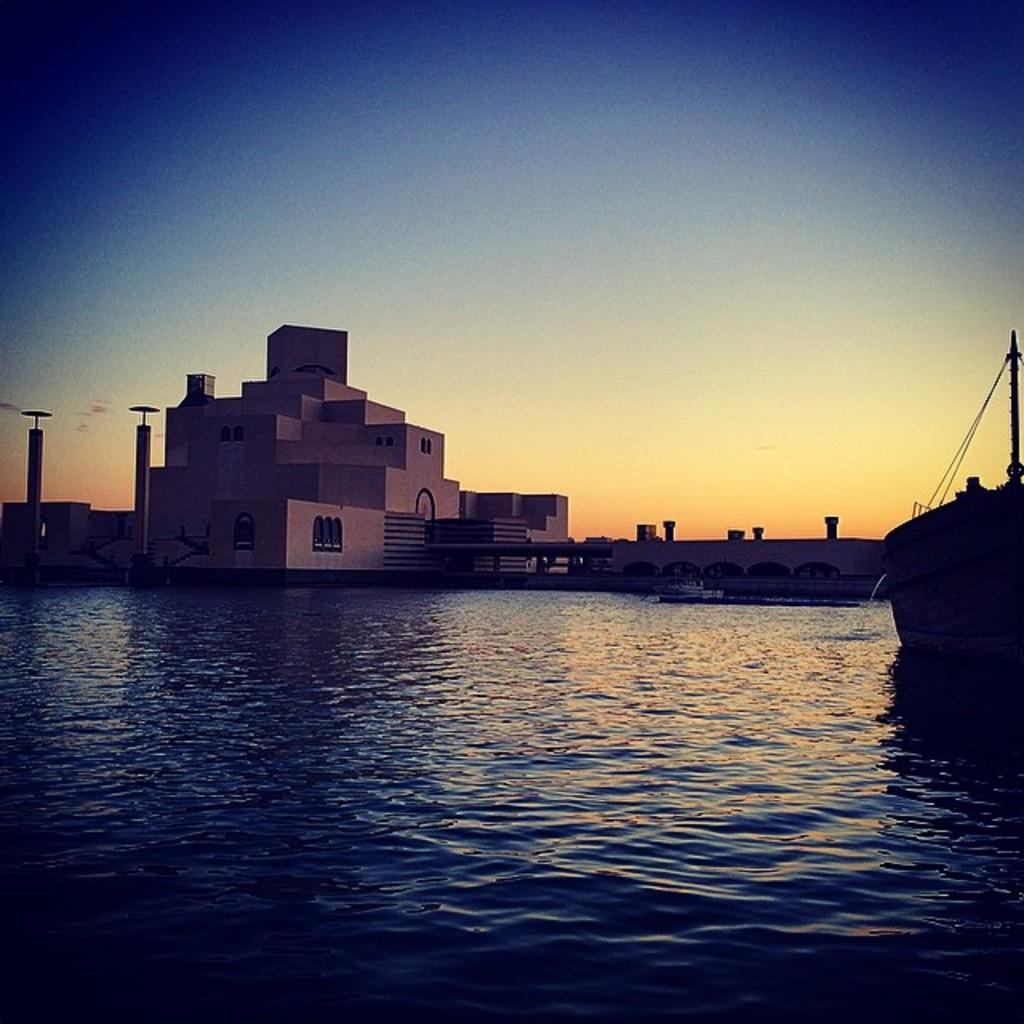What is the main subject in the foreground of the image? There is a boat in the water in the foreground of the image. What can be seen in the background of the image? There is a building, a bridge, and poles in the background of the image. What is visible at the top of the image? The sky is visible at the top of the image. When was the image taken? The image was taken in the evening. What beginner's request can be heard from the fowl in the image? There are no fowl or requests present in the image; it features a boat in the water, a building, a bridge, poles, and the sky. 